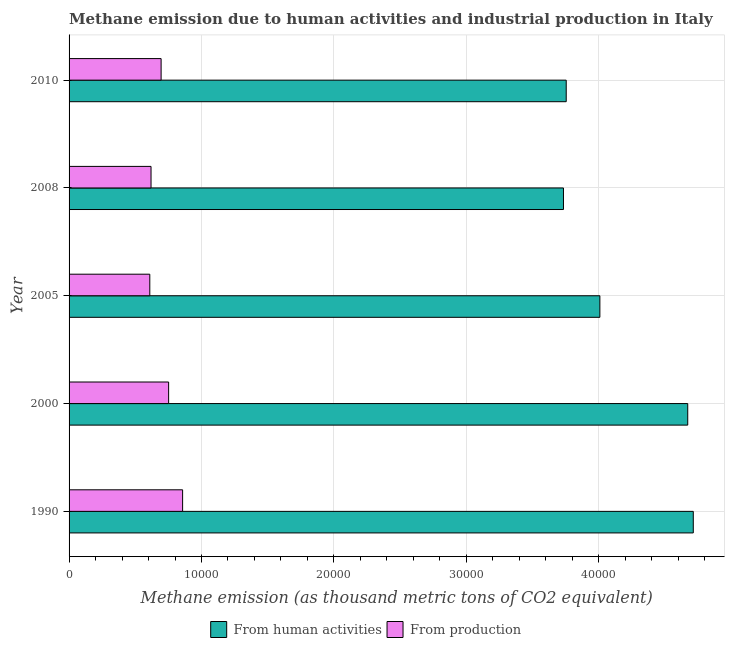How many groups of bars are there?
Offer a very short reply. 5. How many bars are there on the 1st tick from the top?
Your answer should be very brief. 2. How many bars are there on the 1st tick from the bottom?
Provide a succinct answer. 2. What is the label of the 5th group of bars from the top?
Provide a succinct answer. 1990. In how many cases, is the number of bars for a given year not equal to the number of legend labels?
Your answer should be very brief. 0. What is the amount of emissions generated from industries in 2010?
Your response must be concise. 6951.5. Across all years, what is the maximum amount of emissions from human activities?
Give a very brief answer. 4.71e+04. Across all years, what is the minimum amount of emissions generated from industries?
Offer a terse response. 6096.9. What is the total amount of emissions generated from industries in the graph?
Provide a short and direct response. 3.53e+04. What is the difference between the amount of emissions generated from industries in 2005 and that in 2008?
Offer a very short reply. -93.6. What is the difference between the amount of emissions generated from industries in 2000 and the amount of emissions from human activities in 2010?
Your answer should be very brief. -3.00e+04. What is the average amount of emissions generated from industries per year?
Keep it short and to the point. 7066.6. In the year 1990, what is the difference between the amount of emissions from human activities and amount of emissions generated from industries?
Offer a very short reply. 3.86e+04. What is the ratio of the amount of emissions generated from industries in 1990 to that in 2005?
Offer a very short reply. 1.41. Is the amount of emissions generated from industries in 2000 less than that in 2010?
Offer a terse response. No. Is the difference between the amount of emissions from human activities in 1990 and 2000 greater than the difference between the amount of emissions generated from industries in 1990 and 2000?
Your response must be concise. No. What is the difference between the highest and the second highest amount of emissions from human activities?
Your response must be concise. 418.9. What is the difference between the highest and the lowest amount of emissions from human activities?
Offer a very short reply. 9804.1. In how many years, is the amount of emissions from human activities greater than the average amount of emissions from human activities taken over all years?
Your answer should be very brief. 2. Is the sum of the amount of emissions from human activities in 1990 and 2005 greater than the maximum amount of emissions generated from industries across all years?
Give a very brief answer. Yes. What does the 1st bar from the top in 2005 represents?
Your answer should be compact. From production. What does the 2nd bar from the bottom in 2008 represents?
Provide a succinct answer. From production. How many years are there in the graph?
Ensure brevity in your answer.  5. What is the difference between two consecutive major ticks on the X-axis?
Offer a terse response. 10000. Are the values on the major ticks of X-axis written in scientific E-notation?
Provide a short and direct response. No. Does the graph contain any zero values?
Keep it short and to the point. No. Does the graph contain grids?
Give a very brief answer. Yes. What is the title of the graph?
Keep it short and to the point. Methane emission due to human activities and industrial production in Italy. Does "Working capital" appear as one of the legend labels in the graph?
Make the answer very short. No. What is the label or title of the X-axis?
Offer a terse response. Methane emission (as thousand metric tons of CO2 equivalent). What is the label or title of the Y-axis?
Offer a very short reply. Year. What is the Methane emission (as thousand metric tons of CO2 equivalent) of From human activities in 1990?
Keep it short and to the point. 4.71e+04. What is the Methane emission (as thousand metric tons of CO2 equivalent) in From production in 1990?
Give a very brief answer. 8574.9. What is the Methane emission (as thousand metric tons of CO2 equivalent) of From human activities in 2000?
Provide a short and direct response. 4.67e+04. What is the Methane emission (as thousand metric tons of CO2 equivalent) of From production in 2000?
Offer a very short reply. 7519.2. What is the Methane emission (as thousand metric tons of CO2 equivalent) of From human activities in 2005?
Ensure brevity in your answer.  4.01e+04. What is the Methane emission (as thousand metric tons of CO2 equivalent) in From production in 2005?
Your answer should be very brief. 6096.9. What is the Methane emission (as thousand metric tons of CO2 equivalent) in From human activities in 2008?
Keep it short and to the point. 3.73e+04. What is the Methane emission (as thousand metric tons of CO2 equivalent) of From production in 2008?
Keep it short and to the point. 6190.5. What is the Methane emission (as thousand metric tons of CO2 equivalent) of From human activities in 2010?
Provide a short and direct response. 3.75e+04. What is the Methane emission (as thousand metric tons of CO2 equivalent) in From production in 2010?
Offer a very short reply. 6951.5. Across all years, what is the maximum Methane emission (as thousand metric tons of CO2 equivalent) of From human activities?
Offer a terse response. 4.71e+04. Across all years, what is the maximum Methane emission (as thousand metric tons of CO2 equivalent) of From production?
Offer a very short reply. 8574.9. Across all years, what is the minimum Methane emission (as thousand metric tons of CO2 equivalent) of From human activities?
Make the answer very short. 3.73e+04. Across all years, what is the minimum Methane emission (as thousand metric tons of CO2 equivalent) in From production?
Your answer should be very brief. 6096.9. What is the total Methane emission (as thousand metric tons of CO2 equivalent) in From human activities in the graph?
Your answer should be compact. 2.09e+05. What is the total Methane emission (as thousand metric tons of CO2 equivalent) of From production in the graph?
Give a very brief answer. 3.53e+04. What is the difference between the Methane emission (as thousand metric tons of CO2 equivalent) of From human activities in 1990 and that in 2000?
Provide a short and direct response. 418.9. What is the difference between the Methane emission (as thousand metric tons of CO2 equivalent) of From production in 1990 and that in 2000?
Offer a very short reply. 1055.7. What is the difference between the Methane emission (as thousand metric tons of CO2 equivalent) in From human activities in 1990 and that in 2005?
Make the answer very short. 7054.5. What is the difference between the Methane emission (as thousand metric tons of CO2 equivalent) in From production in 1990 and that in 2005?
Provide a succinct answer. 2478. What is the difference between the Methane emission (as thousand metric tons of CO2 equivalent) in From human activities in 1990 and that in 2008?
Provide a short and direct response. 9804.1. What is the difference between the Methane emission (as thousand metric tons of CO2 equivalent) in From production in 1990 and that in 2008?
Offer a terse response. 2384.4. What is the difference between the Methane emission (as thousand metric tons of CO2 equivalent) of From human activities in 1990 and that in 2010?
Ensure brevity in your answer.  9595.9. What is the difference between the Methane emission (as thousand metric tons of CO2 equivalent) of From production in 1990 and that in 2010?
Keep it short and to the point. 1623.4. What is the difference between the Methane emission (as thousand metric tons of CO2 equivalent) in From human activities in 2000 and that in 2005?
Provide a succinct answer. 6635.6. What is the difference between the Methane emission (as thousand metric tons of CO2 equivalent) of From production in 2000 and that in 2005?
Your answer should be very brief. 1422.3. What is the difference between the Methane emission (as thousand metric tons of CO2 equivalent) in From human activities in 2000 and that in 2008?
Your response must be concise. 9385.2. What is the difference between the Methane emission (as thousand metric tons of CO2 equivalent) of From production in 2000 and that in 2008?
Offer a very short reply. 1328.7. What is the difference between the Methane emission (as thousand metric tons of CO2 equivalent) in From human activities in 2000 and that in 2010?
Your answer should be compact. 9177. What is the difference between the Methane emission (as thousand metric tons of CO2 equivalent) of From production in 2000 and that in 2010?
Offer a terse response. 567.7. What is the difference between the Methane emission (as thousand metric tons of CO2 equivalent) in From human activities in 2005 and that in 2008?
Your answer should be very brief. 2749.6. What is the difference between the Methane emission (as thousand metric tons of CO2 equivalent) in From production in 2005 and that in 2008?
Ensure brevity in your answer.  -93.6. What is the difference between the Methane emission (as thousand metric tons of CO2 equivalent) in From human activities in 2005 and that in 2010?
Your answer should be very brief. 2541.4. What is the difference between the Methane emission (as thousand metric tons of CO2 equivalent) of From production in 2005 and that in 2010?
Your answer should be compact. -854.6. What is the difference between the Methane emission (as thousand metric tons of CO2 equivalent) in From human activities in 2008 and that in 2010?
Keep it short and to the point. -208.2. What is the difference between the Methane emission (as thousand metric tons of CO2 equivalent) of From production in 2008 and that in 2010?
Make the answer very short. -761. What is the difference between the Methane emission (as thousand metric tons of CO2 equivalent) in From human activities in 1990 and the Methane emission (as thousand metric tons of CO2 equivalent) in From production in 2000?
Give a very brief answer. 3.96e+04. What is the difference between the Methane emission (as thousand metric tons of CO2 equivalent) in From human activities in 1990 and the Methane emission (as thousand metric tons of CO2 equivalent) in From production in 2005?
Provide a short and direct response. 4.10e+04. What is the difference between the Methane emission (as thousand metric tons of CO2 equivalent) of From human activities in 1990 and the Methane emission (as thousand metric tons of CO2 equivalent) of From production in 2008?
Provide a short and direct response. 4.10e+04. What is the difference between the Methane emission (as thousand metric tons of CO2 equivalent) of From human activities in 1990 and the Methane emission (as thousand metric tons of CO2 equivalent) of From production in 2010?
Make the answer very short. 4.02e+04. What is the difference between the Methane emission (as thousand metric tons of CO2 equivalent) in From human activities in 2000 and the Methane emission (as thousand metric tons of CO2 equivalent) in From production in 2005?
Make the answer very short. 4.06e+04. What is the difference between the Methane emission (as thousand metric tons of CO2 equivalent) in From human activities in 2000 and the Methane emission (as thousand metric tons of CO2 equivalent) in From production in 2008?
Provide a short and direct response. 4.05e+04. What is the difference between the Methane emission (as thousand metric tons of CO2 equivalent) of From human activities in 2000 and the Methane emission (as thousand metric tons of CO2 equivalent) of From production in 2010?
Give a very brief answer. 3.98e+04. What is the difference between the Methane emission (as thousand metric tons of CO2 equivalent) of From human activities in 2005 and the Methane emission (as thousand metric tons of CO2 equivalent) of From production in 2008?
Provide a succinct answer. 3.39e+04. What is the difference between the Methane emission (as thousand metric tons of CO2 equivalent) of From human activities in 2005 and the Methane emission (as thousand metric tons of CO2 equivalent) of From production in 2010?
Give a very brief answer. 3.31e+04. What is the difference between the Methane emission (as thousand metric tons of CO2 equivalent) in From human activities in 2008 and the Methane emission (as thousand metric tons of CO2 equivalent) in From production in 2010?
Provide a succinct answer. 3.04e+04. What is the average Methane emission (as thousand metric tons of CO2 equivalent) of From human activities per year?
Your answer should be very brief. 4.18e+04. What is the average Methane emission (as thousand metric tons of CO2 equivalent) of From production per year?
Offer a very short reply. 7066.6. In the year 1990, what is the difference between the Methane emission (as thousand metric tons of CO2 equivalent) of From human activities and Methane emission (as thousand metric tons of CO2 equivalent) of From production?
Offer a terse response. 3.86e+04. In the year 2000, what is the difference between the Methane emission (as thousand metric tons of CO2 equivalent) in From human activities and Methane emission (as thousand metric tons of CO2 equivalent) in From production?
Give a very brief answer. 3.92e+04. In the year 2005, what is the difference between the Methane emission (as thousand metric tons of CO2 equivalent) in From human activities and Methane emission (as thousand metric tons of CO2 equivalent) in From production?
Your response must be concise. 3.40e+04. In the year 2008, what is the difference between the Methane emission (as thousand metric tons of CO2 equivalent) in From human activities and Methane emission (as thousand metric tons of CO2 equivalent) in From production?
Give a very brief answer. 3.11e+04. In the year 2010, what is the difference between the Methane emission (as thousand metric tons of CO2 equivalent) of From human activities and Methane emission (as thousand metric tons of CO2 equivalent) of From production?
Offer a terse response. 3.06e+04. What is the ratio of the Methane emission (as thousand metric tons of CO2 equivalent) of From human activities in 1990 to that in 2000?
Give a very brief answer. 1.01. What is the ratio of the Methane emission (as thousand metric tons of CO2 equivalent) of From production in 1990 to that in 2000?
Provide a short and direct response. 1.14. What is the ratio of the Methane emission (as thousand metric tons of CO2 equivalent) in From human activities in 1990 to that in 2005?
Keep it short and to the point. 1.18. What is the ratio of the Methane emission (as thousand metric tons of CO2 equivalent) in From production in 1990 to that in 2005?
Provide a succinct answer. 1.41. What is the ratio of the Methane emission (as thousand metric tons of CO2 equivalent) in From human activities in 1990 to that in 2008?
Give a very brief answer. 1.26. What is the ratio of the Methane emission (as thousand metric tons of CO2 equivalent) of From production in 1990 to that in 2008?
Your answer should be very brief. 1.39. What is the ratio of the Methane emission (as thousand metric tons of CO2 equivalent) of From human activities in 1990 to that in 2010?
Make the answer very short. 1.26. What is the ratio of the Methane emission (as thousand metric tons of CO2 equivalent) in From production in 1990 to that in 2010?
Offer a terse response. 1.23. What is the ratio of the Methane emission (as thousand metric tons of CO2 equivalent) in From human activities in 2000 to that in 2005?
Give a very brief answer. 1.17. What is the ratio of the Methane emission (as thousand metric tons of CO2 equivalent) of From production in 2000 to that in 2005?
Your answer should be very brief. 1.23. What is the ratio of the Methane emission (as thousand metric tons of CO2 equivalent) of From human activities in 2000 to that in 2008?
Offer a very short reply. 1.25. What is the ratio of the Methane emission (as thousand metric tons of CO2 equivalent) of From production in 2000 to that in 2008?
Ensure brevity in your answer.  1.21. What is the ratio of the Methane emission (as thousand metric tons of CO2 equivalent) in From human activities in 2000 to that in 2010?
Your answer should be compact. 1.24. What is the ratio of the Methane emission (as thousand metric tons of CO2 equivalent) in From production in 2000 to that in 2010?
Your answer should be very brief. 1.08. What is the ratio of the Methane emission (as thousand metric tons of CO2 equivalent) of From human activities in 2005 to that in 2008?
Make the answer very short. 1.07. What is the ratio of the Methane emission (as thousand metric tons of CO2 equivalent) in From production in 2005 to that in 2008?
Your answer should be very brief. 0.98. What is the ratio of the Methane emission (as thousand metric tons of CO2 equivalent) of From human activities in 2005 to that in 2010?
Your answer should be compact. 1.07. What is the ratio of the Methane emission (as thousand metric tons of CO2 equivalent) in From production in 2005 to that in 2010?
Offer a terse response. 0.88. What is the ratio of the Methane emission (as thousand metric tons of CO2 equivalent) of From human activities in 2008 to that in 2010?
Ensure brevity in your answer.  0.99. What is the ratio of the Methane emission (as thousand metric tons of CO2 equivalent) in From production in 2008 to that in 2010?
Your answer should be very brief. 0.89. What is the difference between the highest and the second highest Methane emission (as thousand metric tons of CO2 equivalent) in From human activities?
Keep it short and to the point. 418.9. What is the difference between the highest and the second highest Methane emission (as thousand metric tons of CO2 equivalent) of From production?
Your answer should be compact. 1055.7. What is the difference between the highest and the lowest Methane emission (as thousand metric tons of CO2 equivalent) in From human activities?
Make the answer very short. 9804.1. What is the difference between the highest and the lowest Methane emission (as thousand metric tons of CO2 equivalent) in From production?
Ensure brevity in your answer.  2478. 